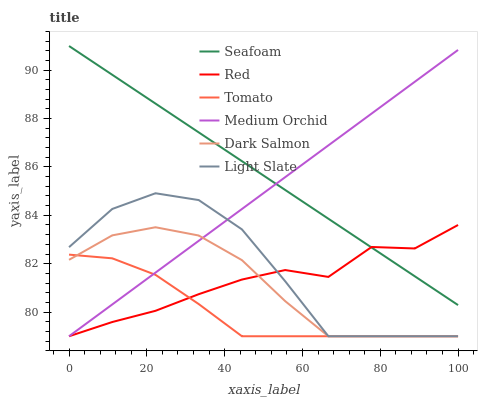Does Tomato have the minimum area under the curve?
Answer yes or no. Yes. Does Seafoam have the maximum area under the curve?
Answer yes or no. Yes. Does Light Slate have the minimum area under the curve?
Answer yes or no. No. Does Light Slate have the maximum area under the curve?
Answer yes or no. No. Is Seafoam the smoothest?
Answer yes or no. Yes. Is Light Slate the roughest?
Answer yes or no. Yes. Is Medium Orchid the smoothest?
Answer yes or no. No. Is Medium Orchid the roughest?
Answer yes or no. No. Does Seafoam have the lowest value?
Answer yes or no. No. Does Seafoam have the highest value?
Answer yes or no. Yes. Does Light Slate have the highest value?
Answer yes or no. No. Is Light Slate less than Seafoam?
Answer yes or no. Yes. Is Seafoam greater than Tomato?
Answer yes or no. Yes. Does Light Slate intersect Seafoam?
Answer yes or no. No. 